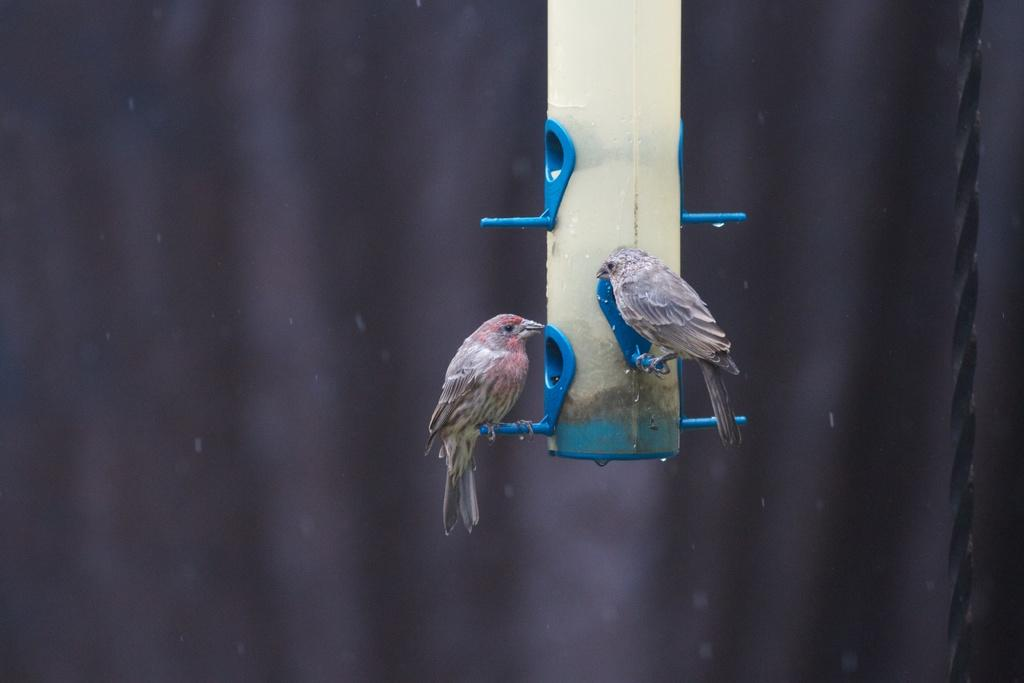How many birds are present in the image? There are two birds in the image. Can you describe the appearance of the birds? The birds are beautiful. What are the birds standing on in the image? The birds are standing on blue color things. What type of decision is the bird making in the image? There is no indication in the image that the bird is making any decision. 